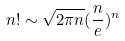<formula> <loc_0><loc_0><loc_500><loc_500>n ! \sim \sqrt { 2 \pi n } ( \frac { n } { e } ) ^ { n }</formula> 